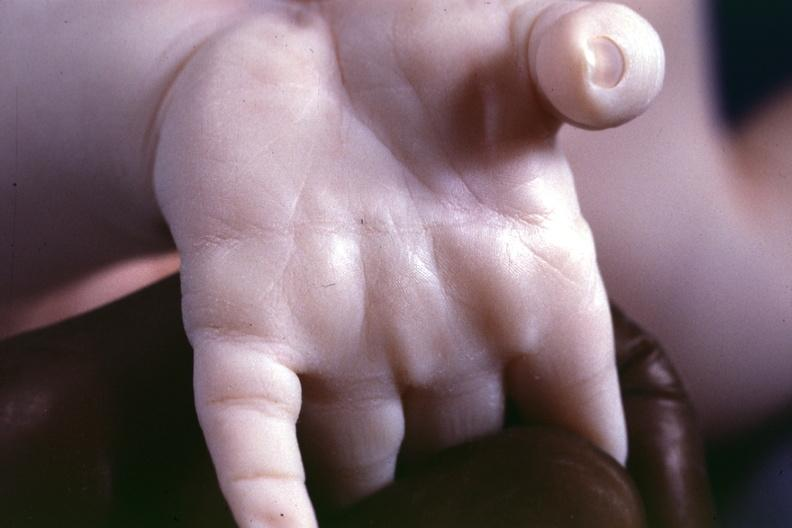what are present?
Answer the question using a single word or phrase. Extremities 